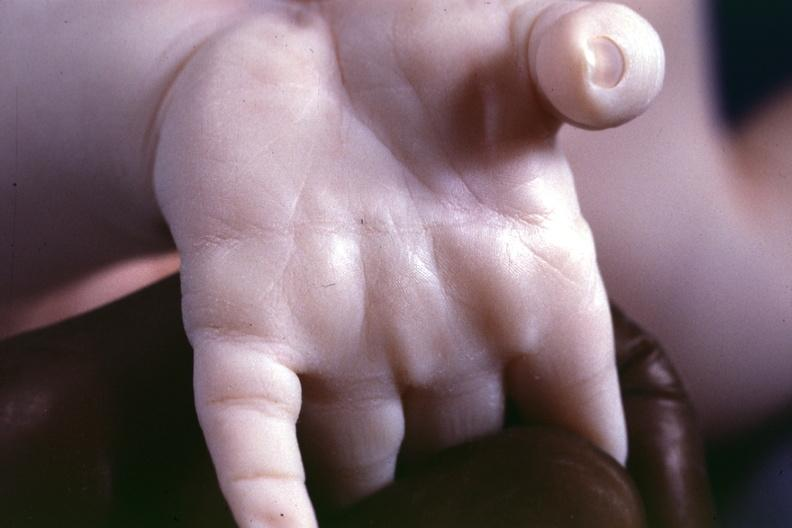what are present?
Answer the question using a single word or phrase. Extremities 